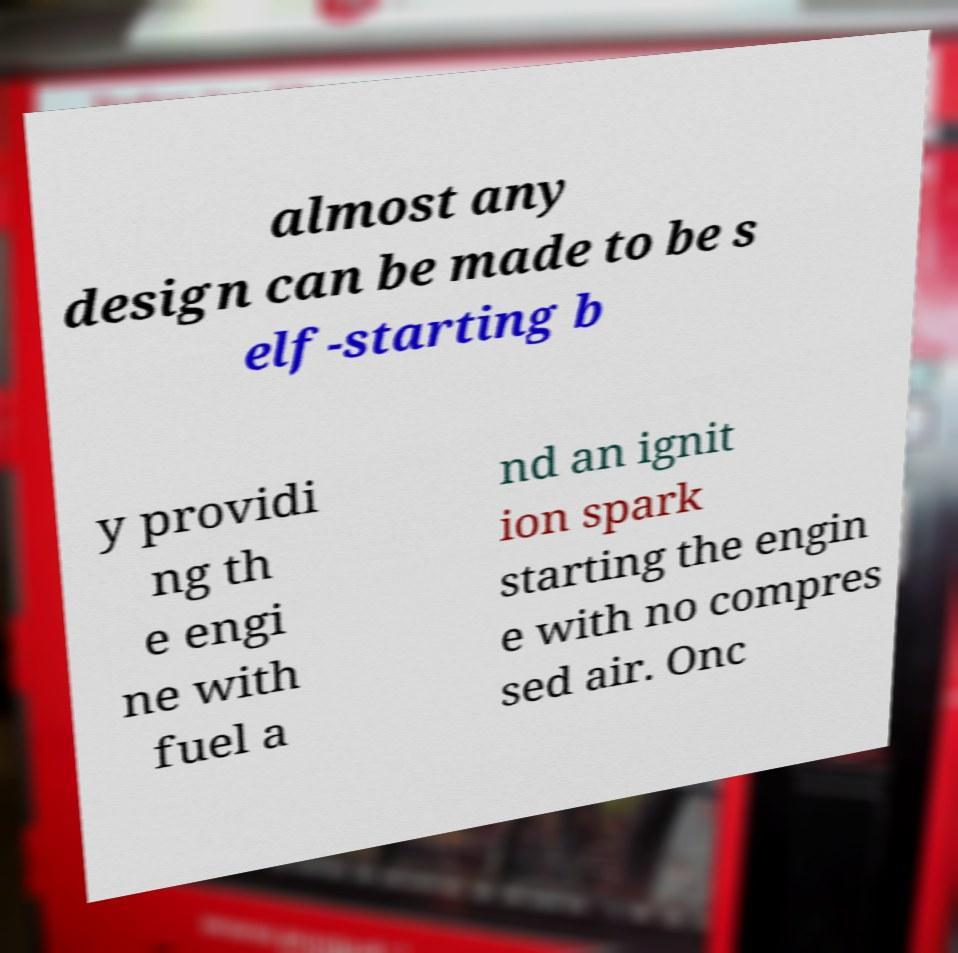Please read and relay the text visible in this image. What does it say? almost any design can be made to be s elf-starting b y providi ng th e engi ne with fuel a nd an ignit ion spark starting the engin e with no compres sed air. Onc 